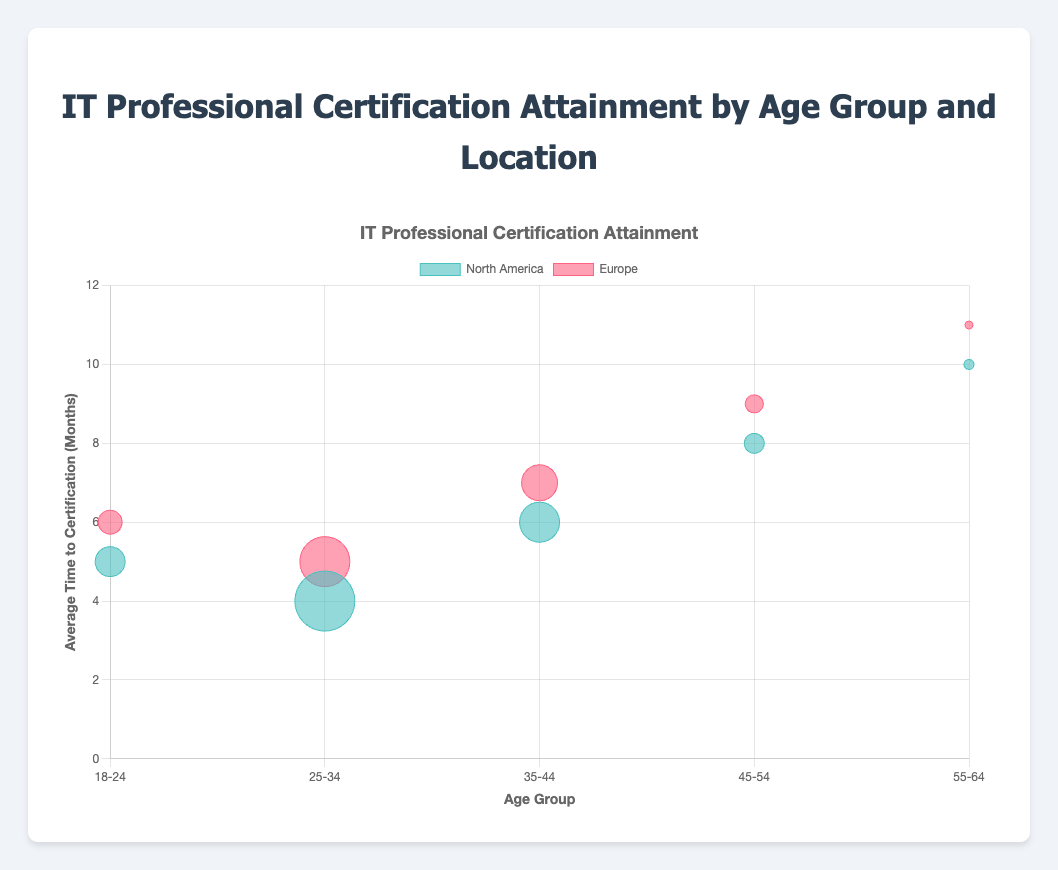What is the title of the chart? The title of the chart is displayed at the top and it is "IT Professional Certification Attainment by Age Group and Location."
Answer: IT Professional Certification Attainment by Age Group and Location Which age group in North America has the maximum number of certifications? By observing the bubble sizes for North America, the largest bubble, indicating the highest number of certifications, is in the "25-34" age group.
Answer: 25-34 What is the average time to certification for the "18-24" age group in North America? Find the bubble labeled as North America in the "18-24" age group on the x-axis. The y-axis value for this bubble represents the average time to certification, which is 5 months.
Answer: 5 months How many data points are there in total in the bubble chart? Count each data point from both North America and Europe across all age groups. There are 5 age groups and 2 locations, resulting in 10 data points in total.
Answer: 10 Which location shows a generally shorter average time to certification across all age groups? Compare the average time to certification (y-axis values) for each age group between North America and Europe. North America consistently shows lower values, indicating a shorter average time to certification.
Answer: North America What is the difference in the average time to certification between the "25-34" age group and the "45-54" age group in Europe? Find the average time to certification for the "25-34" (5 months) and "45-54" (9 months) age groups in Europe, then calculate the difference: 9 - 5 = 4 months.
Answer: 4 months What is the total number of certifications attained by the "35-44" age group in both North America and Europe combined? Look at the certification numbers for the "35-44" age group in North America (200) and Europe (180), then sum them: 200 + 180 = 380 certifications.
Answer: 380 Which age group in Europe has the least number of certifications? Identify the smallest bubble in Europe; the smallest bubble appears in the "55-64" age group, indicating 40 certifications.
Answer: 55-64 Is the average time to certification for the "55-64" age group in North America more than that in Europe? Compare the y-axis values for the "55-64" group in North America (10 months) and Europe (11 months); the average time in North America is less.
Answer: No By how much does the "18-24" age group certification count in North America outnumber that in Europe? Check the certification counts for the "18-24" group: North America (150) and Europe (120). The difference is 150 - 120 = 30.
Answer: 30 